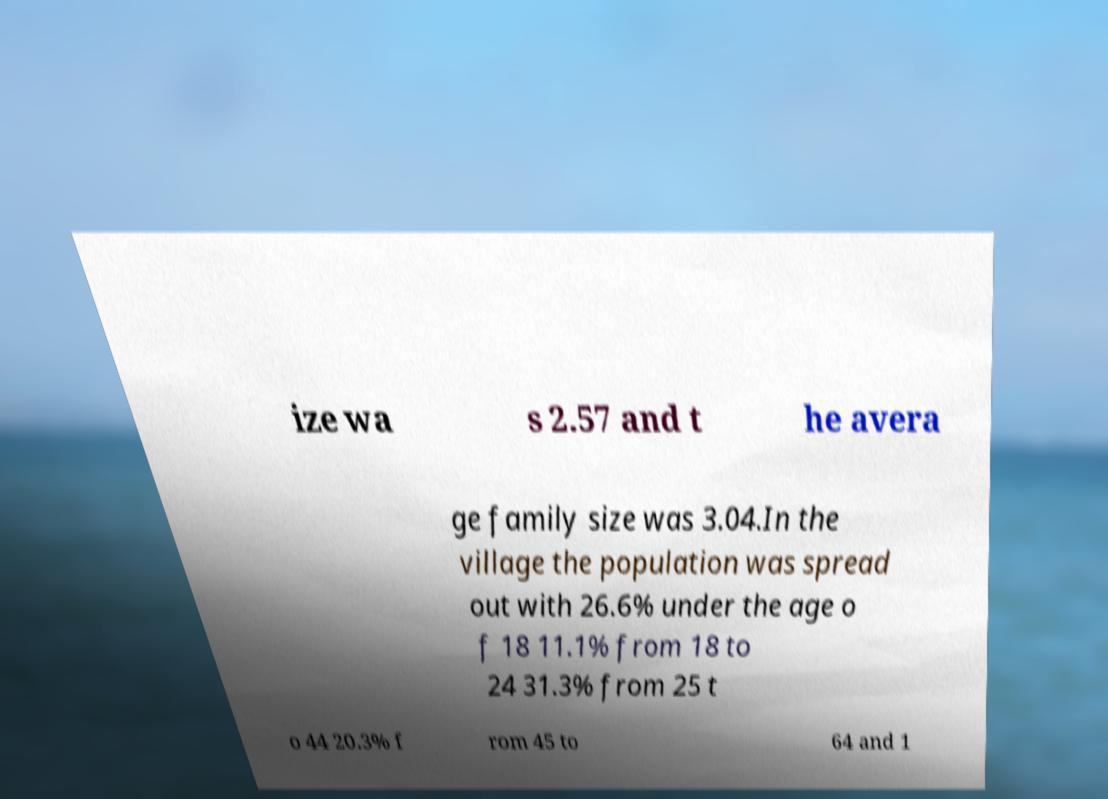Please read and relay the text visible in this image. What does it say? ize wa s 2.57 and t he avera ge family size was 3.04.In the village the population was spread out with 26.6% under the age o f 18 11.1% from 18 to 24 31.3% from 25 t o 44 20.3% f rom 45 to 64 and 1 